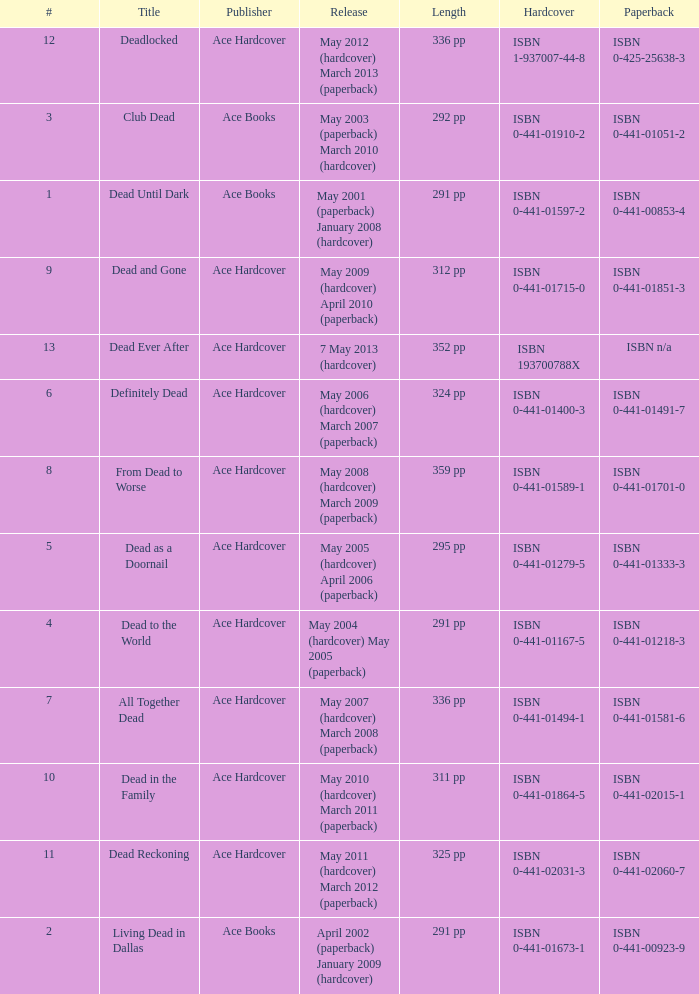How many publishers put out isbn 193700788x? 1.0. 